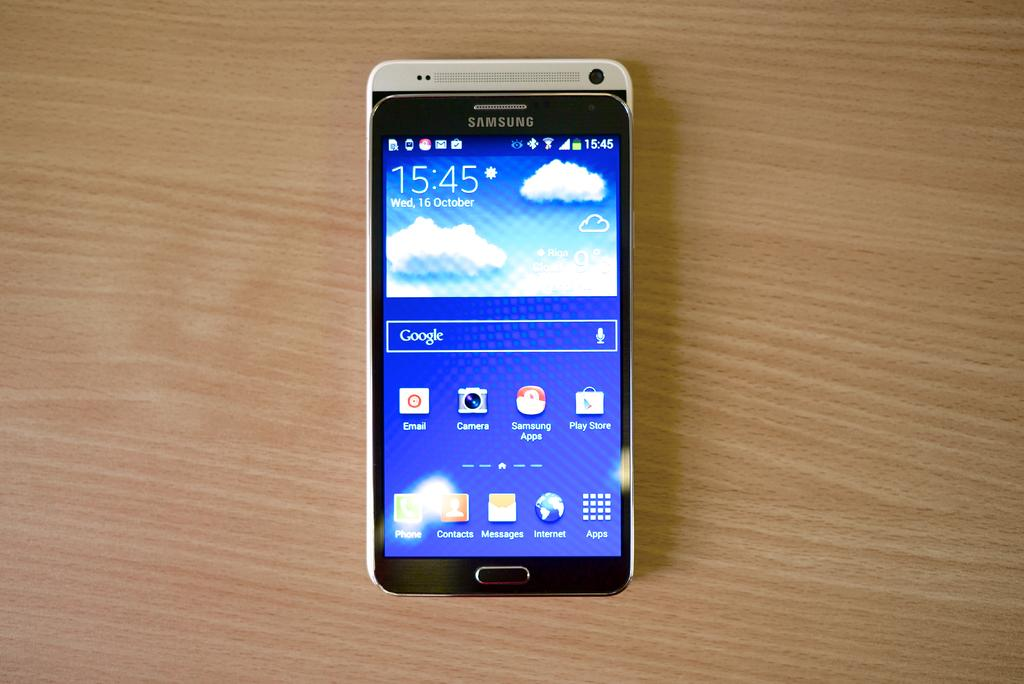<image>
Present a compact description of the photo's key features. A Samsung phone has a blue background displaying the date as October 16. 